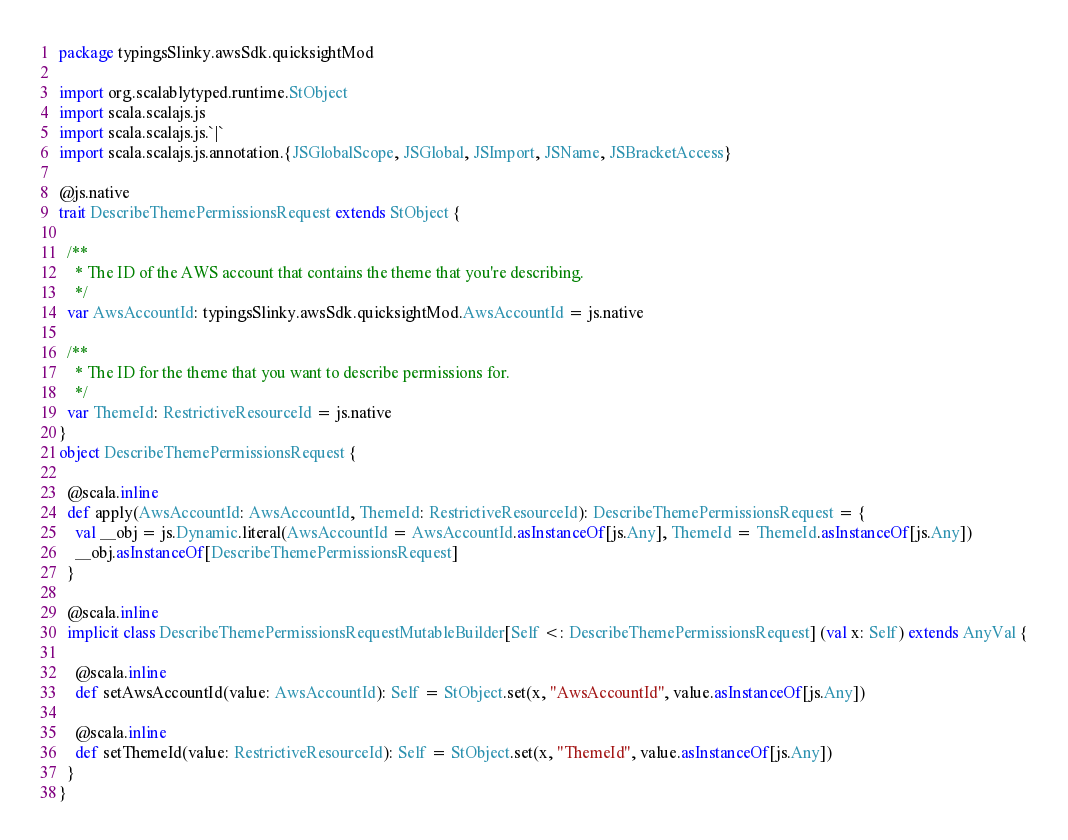<code> <loc_0><loc_0><loc_500><loc_500><_Scala_>package typingsSlinky.awsSdk.quicksightMod

import org.scalablytyped.runtime.StObject
import scala.scalajs.js
import scala.scalajs.js.`|`
import scala.scalajs.js.annotation.{JSGlobalScope, JSGlobal, JSImport, JSName, JSBracketAccess}

@js.native
trait DescribeThemePermissionsRequest extends StObject {
  
  /**
    * The ID of the AWS account that contains the theme that you're describing.
    */
  var AwsAccountId: typingsSlinky.awsSdk.quicksightMod.AwsAccountId = js.native
  
  /**
    * The ID for the theme that you want to describe permissions for.
    */
  var ThemeId: RestrictiveResourceId = js.native
}
object DescribeThemePermissionsRequest {
  
  @scala.inline
  def apply(AwsAccountId: AwsAccountId, ThemeId: RestrictiveResourceId): DescribeThemePermissionsRequest = {
    val __obj = js.Dynamic.literal(AwsAccountId = AwsAccountId.asInstanceOf[js.Any], ThemeId = ThemeId.asInstanceOf[js.Any])
    __obj.asInstanceOf[DescribeThemePermissionsRequest]
  }
  
  @scala.inline
  implicit class DescribeThemePermissionsRequestMutableBuilder[Self <: DescribeThemePermissionsRequest] (val x: Self) extends AnyVal {
    
    @scala.inline
    def setAwsAccountId(value: AwsAccountId): Self = StObject.set(x, "AwsAccountId", value.asInstanceOf[js.Any])
    
    @scala.inline
    def setThemeId(value: RestrictiveResourceId): Self = StObject.set(x, "ThemeId", value.asInstanceOf[js.Any])
  }
}
</code> 